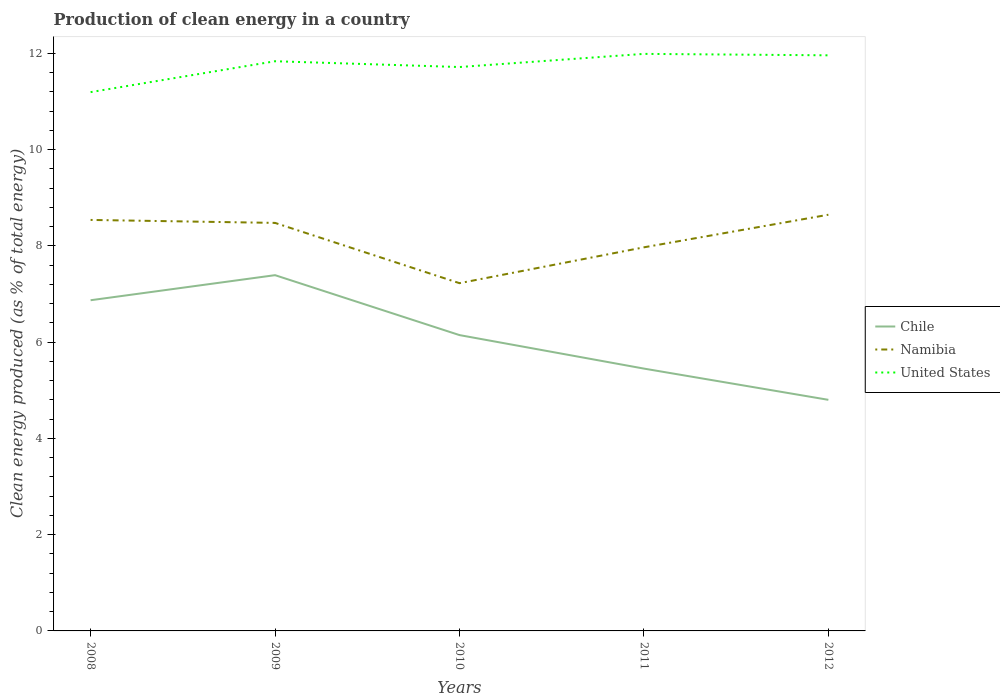How many different coloured lines are there?
Offer a very short reply. 3. Does the line corresponding to Chile intersect with the line corresponding to United States?
Make the answer very short. No. Across all years, what is the maximum percentage of clean energy produced in United States?
Your answer should be very brief. 11.2. In which year was the percentage of clean energy produced in United States maximum?
Ensure brevity in your answer.  2008. What is the total percentage of clean energy produced in United States in the graph?
Provide a short and direct response. -0.52. What is the difference between the highest and the second highest percentage of clean energy produced in Namibia?
Give a very brief answer. 1.42. What is the difference between the highest and the lowest percentage of clean energy produced in Namibia?
Provide a succinct answer. 3. Is the percentage of clean energy produced in Namibia strictly greater than the percentage of clean energy produced in Chile over the years?
Keep it short and to the point. No. How many lines are there?
Your answer should be very brief. 3. Are the values on the major ticks of Y-axis written in scientific E-notation?
Make the answer very short. No. Does the graph contain grids?
Keep it short and to the point. No. How many legend labels are there?
Your answer should be very brief. 3. What is the title of the graph?
Ensure brevity in your answer.  Production of clean energy in a country. What is the label or title of the Y-axis?
Make the answer very short. Clean energy produced (as % of total energy). What is the Clean energy produced (as % of total energy) of Chile in 2008?
Your answer should be very brief. 6.87. What is the Clean energy produced (as % of total energy) of Namibia in 2008?
Offer a terse response. 8.54. What is the Clean energy produced (as % of total energy) in United States in 2008?
Provide a short and direct response. 11.2. What is the Clean energy produced (as % of total energy) in Chile in 2009?
Your answer should be compact. 7.39. What is the Clean energy produced (as % of total energy) of Namibia in 2009?
Your answer should be compact. 8.48. What is the Clean energy produced (as % of total energy) of United States in 2009?
Ensure brevity in your answer.  11.84. What is the Clean energy produced (as % of total energy) in Chile in 2010?
Offer a terse response. 6.15. What is the Clean energy produced (as % of total energy) of Namibia in 2010?
Keep it short and to the point. 7.23. What is the Clean energy produced (as % of total energy) of United States in 2010?
Your answer should be compact. 11.72. What is the Clean energy produced (as % of total energy) of Chile in 2011?
Your response must be concise. 5.45. What is the Clean energy produced (as % of total energy) of Namibia in 2011?
Offer a terse response. 7.97. What is the Clean energy produced (as % of total energy) in United States in 2011?
Provide a short and direct response. 11.99. What is the Clean energy produced (as % of total energy) in Chile in 2012?
Your response must be concise. 4.8. What is the Clean energy produced (as % of total energy) of Namibia in 2012?
Your response must be concise. 8.65. What is the Clean energy produced (as % of total energy) in United States in 2012?
Provide a short and direct response. 11.96. Across all years, what is the maximum Clean energy produced (as % of total energy) of Chile?
Your response must be concise. 7.39. Across all years, what is the maximum Clean energy produced (as % of total energy) in Namibia?
Make the answer very short. 8.65. Across all years, what is the maximum Clean energy produced (as % of total energy) in United States?
Offer a terse response. 11.99. Across all years, what is the minimum Clean energy produced (as % of total energy) of Chile?
Make the answer very short. 4.8. Across all years, what is the minimum Clean energy produced (as % of total energy) in Namibia?
Offer a very short reply. 7.23. Across all years, what is the minimum Clean energy produced (as % of total energy) in United States?
Your answer should be very brief. 11.2. What is the total Clean energy produced (as % of total energy) in Chile in the graph?
Ensure brevity in your answer.  30.67. What is the total Clean energy produced (as % of total energy) in Namibia in the graph?
Make the answer very short. 40.87. What is the total Clean energy produced (as % of total energy) of United States in the graph?
Offer a very short reply. 58.71. What is the difference between the Clean energy produced (as % of total energy) of Chile in 2008 and that in 2009?
Offer a terse response. -0.52. What is the difference between the Clean energy produced (as % of total energy) of Namibia in 2008 and that in 2009?
Offer a very short reply. 0.06. What is the difference between the Clean energy produced (as % of total energy) in United States in 2008 and that in 2009?
Your answer should be very brief. -0.64. What is the difference between the Clean energy produced (as % of total energy) of Chile in 2008 and that in 2010?
Offer a very short reply. 0.72. What is the difference between the Clean energy produced (as % of total energy) of Namibia in 2008 and that in 2010?
Make the answer very short. 1.31. What is the difference between the Clean energy produced (as % of total energy) in United States in 2008 and that in 2010?
Make the answer very short. -0.52. What is the difference between the Clean energy produced (as % of total energy) of Chile in 2008 and that in 2011?
Keep it short and to the point. 1.42. What is the difference between the Clean energy produced (as % of total energy) in Namibia in 2008 and that in 2011?
Offer a very short reply. 0.57. What is the difference between the Clean energy produced (as % of total energy) of United States in 2008 and that in 2011?
Your answer should be very brief. -0.79. What is the difference between the Clean energy produced (as % of total energy) in Chile in 2008 and that in 2012?
Your answer should be very brief. 2.07. What is the difference between the Clean energy produced (as % of total energy) of Namibia in 2008 and that in 2012?
Ensure brevity in your answer.  -0.11. What is the difference between the Clean energy produced (as % of total energy) of United States in 2008 and that in 2012?
Your answer should be compact. -0.76. What is the difference between the Clean energy produced (as % of total energy) of Chile in 2009 and that in 2010?
Provide a short and direct response. 1.25. What is the difference between the Clean energy produced (as % of total energy) in Namibia in 2009 and that in 2010?
Give a very brief answer. 1.25. What is the difference between the Clean energy produced (as % of total energy) of United States in 2009 and that in 2010?
Ensure brevity in your answer.  0.12. What is the difference between the Clean energy produced (as % of total energy) in Chile in 2009 and that in 2011?
Make the answer very short. 1.94. What is the difference between the Clean energy produced (as % of total energy) in Namibia in 2009 and that in 2011?
Keep it short and to the point. 0.51. What is the difference between the Clean energy produced (as % of total energy) of United States in 2009 and that in 2011?
Offer a very short reply. -0.15. What is the difference between the Clean energy produced (as % of total energy) in Chile in 2009 and that in 2012?
Offer a very short reply. 2.59. What is the difference between the Clean energy produced (as % of total energy) in Namibia in 2009 and that in 2012?
Give a very brief answer. -0.17. What is the difference between the Clean energy produced (as % of total energy) in United States in 2009 and that in 2012?
Give a very brief answer. -0.12. What is the difference between the Clean energy produced (as % of total energy) of Chile in 2010 and that in 2011?
Your response must be concise. 0.7. What is the difference between the Clean energy produced (as % of total energy) in Namibia in 2010 and that in 2011?
Provide a succinct answer. -0.75. What is the difference between the Clean energy produced (as % of total energy) of United States in 2010 and that in 2011?
Give a very brief answer. -0.27. What is the difference between the Clean energy produced (as % of total energy) in Chile in 2010 and that in 2012?
Offer a very short reply. 1.35. What is the difference between the Clean energy produced (as % of total energy) of Namibia in 2010 and that in 2012?
Your answer should be very brief. -1.42. What is the difference between the Clean energy produced (as % of total energy) in United States in 2010 and that in 2012?
Give a very brief answer. -0.24. What is the difference between the Clean energy produced (as % of total energy) in Chile in 2011 and that in 2012?
Offer a very short reply. 0.65. What is the difference between the Clean energy produced (as % of total energy) of Namibia in 2011 and that in 2012?
Ensure brevity in your answer.  -0.68. What is the difference between the Clean energy produced (as % of total energy) in United States in 2011 and that in 2012?
Keep it short and to the point. 0.03. What is the difference between the Clean energy produced (as % of total energy) in Chile in 2008 and the Clean energy produced (as % of total energy) in Namibia in 2009?
Your answer should be compact. -1.61. What is the difference between the Clean energy produced (as % of total energy) of Chile in 2008 and the Clean energy produced (as % of total energy) of United States in 2009?
Your answer should be compact. -4.97. What is the difference between the Clean energy produced (as % of total energy) of Namibia in 2008 and the Clean energy produced (as % of total energy) of United States in 2009?
Provide a short and direct response. -3.3. What is the difference between the Clean energy produced (as % of total energy) in Chile in 2008 and the Clean energy produced (as % of total energy) in Namibia in 2010?
Give a very brief answer. -0.35. What is the difference between the Clean energy produced (as % of total energy) of Chile in 2008 and the Clean energy produced (as % of total energy) of United States in 2010?
Make the answer very short. -4.85. What is the difference between the Clean energy produced (as % of total energy) of Namibia in 2008 and the Clean energy produced (as % of total energy) of United States in 2010?
Provide a succinct answer. -3.18. What is the difference between the Clean energy produced (as % of total energy) in Chile in 2008 and the Clean energy produced (as % of total energy) in Namibia in 2011?
Offer a very short reply. -1.1. What is the difference between the Clean energy produced (as % of total energy) of Chile in 2008 and the Clean energy produced (as % of total energy) of United States in 2011?
Ensure brevity in your answer.  -5.12. What is the difference between the Clean energy produced (as % of total energy) of Namibia in 2008 and the Clean energy produced (as % of total energy) of United States in 2011?
Your answer should be very brief. -3.45. What is the difference between the Clean energy produced (as % of total energy) in Chile in 2008 and the Clean energy produced (as % of total energy) in Namibia in 2012?
Offer a terse response. -1.78. What is the difference between the Clean energy produced (as % of total energy) in Chile in 2008 and the Clean energy produced (as % of total energy) in United States in 2012?
Your answer should be compact. -5.09. What is the difference between the Clean energy produced (as % of total energy) in Namibia in 2008 and the Clean energy produced (as % of total energy) in United States in 2012?
Offer a very short reply. -3.42. What is the difference between the Clean energy produced (as % of total energy) in Chile in 2009 and the Clean energy produced (as % of total energy) in Namibia in 2010?
Ensure brevity in your answer.  0.17. What is the difference between the Clean energy produced (as % of total energy) in Chile in 2009 and the Clean energy produced (as % of total energy) in United States in 2010?
Offer a very short reply. -4.33. What is the difference between the Clean energy produced (as % of total energy) in Namibia in 2009 and the Clean energy produced (as % of total energy) in United States in 2010?
Give a very brief answer. -3.24. What is the difference between the Clean energy produced (as % of total energy) of Chile in 2009 and the Clean energy produced (as % of total energy) of Namibia in 2011?
Offer a terse response. -0.58. What is the difference between the Clean energy produced (as % of total energy) in Chile in 2009 and the Clean energy produced (as % of total energy) in United States in 2011?
Give a very brief answer. -4.6. What is the difference between the Clean energy produced (as % of total energy) of Namibia in 2009 and the Clean energy produced (as % of total energy) of United States in 2011?
Your answer should be very brief. -3.51. What is the difference between the Clean energy produced (as % of total energy) in Chile in 2009 and the Clean energy produced (as % of total energy) in Namibia in 2012?
Your answer should be very brief. -1.26. What is the difference between the Clean energy produced (as % of total energy) of Chile in 2009 and the Clean energy produced (as % of total energy) of United States in 2012?
Offer a terse response. -4.57. What is the difference between the Clean energy produced (as % of total energy) of Namibia in 2009 and the Clean energy produced (as % of total energy) of United States in 2012?
Ensure brevity in your answer.  -3.48. What is the difference between the Clean energy produced (as % of total energy) in Chile in 2010 and the Clean energy produced (as % of total energy) in Namibia in 2011?
Your response must be concise. -1.82. What is the difference between the Clean energy produced (as % of total energy) of Chile in 2010 and the Clean energy produced (as % of total energy) of United States in 2011?
Your answer should be compact. -5.84. What is the difference between the Clean energy produced (as % of total energy) in Namibia in 2010 and the Clean energy produced (as % of total energy) in United States in 2011?
Offer a very short reply. -4.77. What is the difference between the Clean energy produced (as % of total energy) in Chile in 2010 and the Clean energy produced (as % of total energy) in Namibia in 2012?
Make the answer very short. -2.5. What is the difference between the Clean energy produced (as % of total energy) of Chile in 2010 and the Clean energy produced (as % of total energy) of United States in 2012?
Make the answer very short. -5.81. What is the difference between the Clean energy produced (as % of total energy) of Namibia in 2010 and the Clean energy produced (as % of total energy) of United States in 2012?
Offer a terse response. -4.74. What is the difference between the Clean energy produced (as % of total energy) in Chile in 2011 and the Clean energy produced (as % of total energy) in Namibia in 2012?
Provide a succinct answer. -3.2. What is the difference between the Clean energy produced (as % of total energy) in Chile in 2011 and the Clean energy produced (as % of total energy) in United States in 2012?
Provide a succinct answer. -6.51. What is the difference between the Clean energy produced (as % of total energy) in Namibia in 2011 and the Clean energy produced (as % of total energy) in United States in 2012?
Your answer should be compact. -3.99. What is the average Clean energy produced (as % of total energy) of Chile per year?
Offer a very short reply. 6.13. What is the average Clean energy produced (as % of total energy) of Namibia per year?
Your response must be concise. 8.17. What is the average Clean energy produced (as % of total energy) in United States per year?
Make the answer very short. 11.74. In the year 2008, what is the difference between the Clean energy produced (as % of total energy) in Chile and Clean energy produced (as % of total energy) in Namibia?
Offer a terse response. -1.67. In the year 2008, what is the difference between the Clean energy produced (as % of total energy) in Chile and Clean energy produced (as % of total energy) in United States?
Offer a very short reply. -4.33. In the year 2008, what is the difference between the Clean energy produced (as % of total energy) of Namibia and Clean energy produced (as % of total energy) of United States?
Ensure brevity in your answer.  -2.66. In the year 2009, what is the difference between the Clean energy produced (as % of total energy) in Chile and Clean energy produced (as % of total energy) in Namibia?
Your answer should be very brief. -1.09. In the year 2009, what is the difference between the Clean energy produced (as % of total energy) in Chile and Clean energy produced (as % of total energy) in United States?
Offer a very short reply. -4.45. In the year 2009, what is the difference between the Clean energy produced (as % of total energy) in Namibia and Clean energy produced (as % of total energy) in United States?
Provide a succinct answer. -3.36. In the year 2010, what is the difference between the Clean energy produced (as % of total energy) in Chile and Clean energy produced (as % of total energy) in Namibia?
Offer a very short reply. -1.08. In the year 2010, what is the difference between the Clean energy produced (as % of total energy) of Chile and Clean energy produced (as % of total energy) of United States?
Offer a very short reply. -5.57. In the year 2010, what is the difference between the Clean energy produced (as % of total energy) of Namibia and Clean energy produced (as % of total energy) of United States?
Provide a succinct answer. -4.49. In the year 2011, what is the difference between the Clean energy produced (as % of total energy) in Chile and Clean energy produced (as % of total energy) in Namibia?
Your answer should be very brief. -2.52. In the year 2011, what is the difference between the Clean energy produced (as % of total energy) of Chile and Clean energy produced (as % of total energy) of United States?
Give a very brief answer. -6.54. In the year 2011, what is the difference between the Clean energy produced (as % of total energy) in Namibia and Clean energy produced (as % of total energy) in United States?
Provide a succinct answer. -4.02. In the year 2012, what is the difference between the Clean energy produced (as % of total energy) in Chile and Clean energy produced (as % of total energy) in Namibia?
Provide a succinct answer. -3.85. In the year 2012, what is the difference between the Clean energy produced (as % of total energy) of Chile and Clean energy produced (as % of total energy) of United States?
Your response must be concise. -7.16. In the year 2012, what is the difference between the Clean energy produced (as % of total energy) in Namibia and Clean energy produced (as % of total energy) in United States?
Keep it short and to the point. -3.31. What is the ratio of the Clean energy produced (as % of total energy) of Chile in 2008 to that in 2009?
Make the answer very short. 0.93. What is the ratio of the Clean energy produced (as % of total energy) in Namibia in 2008 to that in 2009?
Your answer should be compact. 1.01. What is the ratio of the Clean energy produced (as % of total energy) of United States in 2008 to that in 2009?
Provide a short and direct response. 0.95. What is the ratio of the Clean energy produced (as % of total energy) of Chile in 2008 to that in 2010?
Make the answer very short. 1.12. What is the ratio of the Clean energy produced (as % of total energy) of Namibia in 2008 to that in 2010?
Provide a succinct answer. 1.18. What is the ratio of the Clean energy produced (as % of total energy) of United States in 2008 to that in 2010?
Offer a terse response. 0.96. What is the ratio of the Clean energy produced (as % of total energy) in Chile in 2008 to that in 2011?
Your answer should be very brief. 1.26. What is the ratio of the Clean energy produced (as % of total energy) of Namibia in 2008 to that in 2011?
Keep it short and to the point. 1.07. What is the ratio of the Clean energy produced (as % of total energy) of United States in 2008 to that in 2011?
Make the answer very short. 0.93. What is the ratio of the Clean energy produced (as % of total energy) in Chile in 2008 to that in 2012?
Provide a short and direct response. 1.43. What is the ratio of the Clean energy produced (as % of total energy) of Namibia in 2008 to that in 2012?
Offer a very short reply. 0.99. What is the ratio of the Clean energy produced (as % of total energy) in United States in 2008 to that in 2012?
Provide a succinct answer. 0.94. What is the ratio of the Clean energy produced (as % of total energy) in Chile in 2009 to that in 2010?
Offer a terse response. 1.2. What is the ratio of the Clean energy produced (as % of total energy) in Namibia in 2009 to that in 2010?
Give a very brief answer. 1.17. What is the ratio of the Clean energy produced (as % of total energy) of United States in 2009 to that in 2010?
Give a very brief answer. 1.01. What is the ratio of the Clean energy produced (as % of total energy) in Chile in 2009 to that in 2011?
Keep it short and to the point. 1.36. What is the ratio of the Clean energy produced (as % of total energy) in Namibia in 2009 to that in 2011?
Your answer should be compact. 1.06. What is the ratio of the Clean energy produced (as % of total energy) of United States in 2009 to that in 2011?
Make the answer very short. 0.99. What is the ratio of the Clean energy produced (as % of total energy) in Chile in 2009 to that in 2012?
Your response must be concise. 1.54. What is the ratio of the Clean energy produced (as % of total energy) of Namibia in 2009 to that in 2012?
Keep it short and to the point. 0.98. What is the ratio of the Clean energy produced (as % of total energy) in United States in 2009 to that in 2012?
Keep it short and to the point. 0.99. What is the ratio of the Clean energy produced (as % of total energy) in Chile in 2010 to that in 2011?
Keep it short and to the point. 1.13. What is the ratio of the Clean energy produced (as % of total energy) of Namibia in 2010 to that in 2011?
Offer a terse response. 0.91. What is the ratio of the Clean energy produced (as % of total energy) of United States in 2010 to that in 2011?
Give a very brief answer. 0.98. What is the ratio of the Clean energy produced (as % of total energy) in Chile in 2010 to that in 2012?
Your answer should be compact. 1.28. What is the ratio of the Clean energy produced (as % of total energy) in Namibia in 2010 to that in 2012?
Provide a short and direct response. 0.84. What is the ratio of the Clean energy produced (as % of total energy) in United States in 2010 to that in 2012?
Provide a succinct answer. 0.98. What is the ratio of the Clean energy produced (as % of total energy) of Chile in 2011 to that in 2012?
Keep it short and to the point. 1.14. What is the ratio of the Clean energy produced (as % of total energy) of Namibia in 2011 to that in 2012?
Give a very brief answer. 0.92. What is the ratio of the Clean energy produced (as % of total energy) in United States in 2011 to that in 2012?
Provide a succinct answer. 1. What is the difference between the highest and the second highest Clean energy produced (as % of total energy) in Chile?
Your response must be concise. 0.52. What is the difference between the highest and the second highest Clean energy produced (as % of total energy) of Namibia?
Provide a succinct answer. 0.11. What is the difference between the highest and the second highest Clean energy produced (as % of total energy) of United States?
Give a very brief answer. 0.03. What is the difference between the highest and the lowest Clean energy produced (as % of total energy) of Chile?
Make the answer very short. 2.59. What is the difference between the highest and the lowest Clean energy produced (as % of total energy) of Namibia?
Give a very brief answer. 1.42. What is the difference between the highest and the lowest Clean energy produced (as % of total energy) in United States?
Offer a terse response. 0.79. 